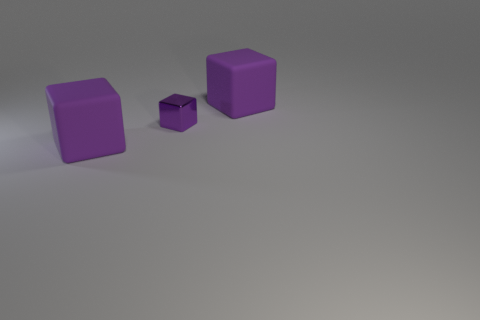Are there any other things that have the same material as the small purple cube?
Offer a very short reply. No. Is there any other thing of the same color as the tiny cube?
Keep it short and to the point. Yes. The small purple object has what shape?
Your response must be concise. Cube. Is the number of yellow metallic balls greater than the number of metal things?
Your answer should be compact. No. Are any large green things visible?
Your answer should be very brief. No. What is the shape of the large purple matte thing that is on the right side of the rubber object to the left of the purple metallic thing?
Your answer should be very brief. Cube. What number of things are either purple objects or purple cubes behind the shiny block?
Ensure brevity in your answer.  3. What is the color of the big object that is behind the big purple rubber cube that is in front of the purple rubber thing that is right of the tiny purple thing?
Offer a terse response. Purple. What color is the small object?
Give a very brief answer. Purple. How many matte things are either tiny cubes or large cubes?
Your response must be concise. 2. 